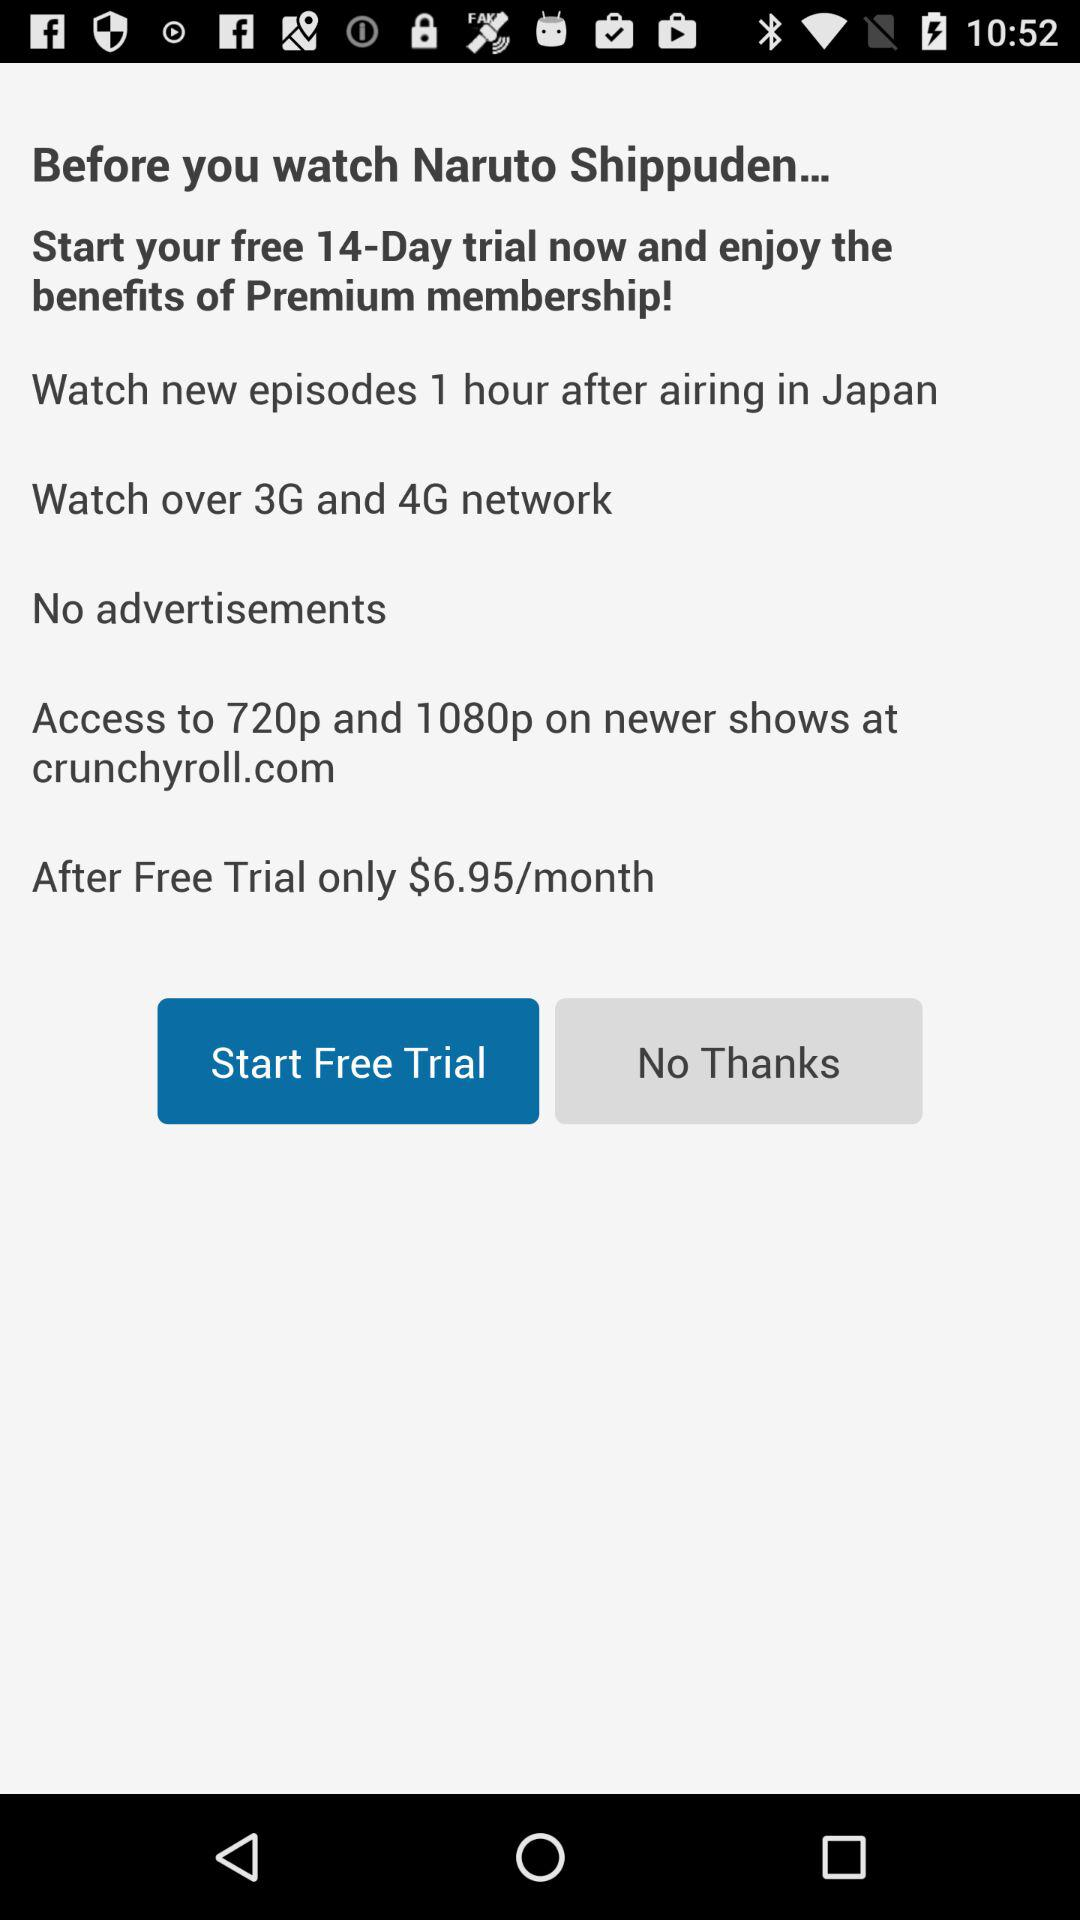How many days does the free trial last?
Answer the question using a single word or phrase. 14 